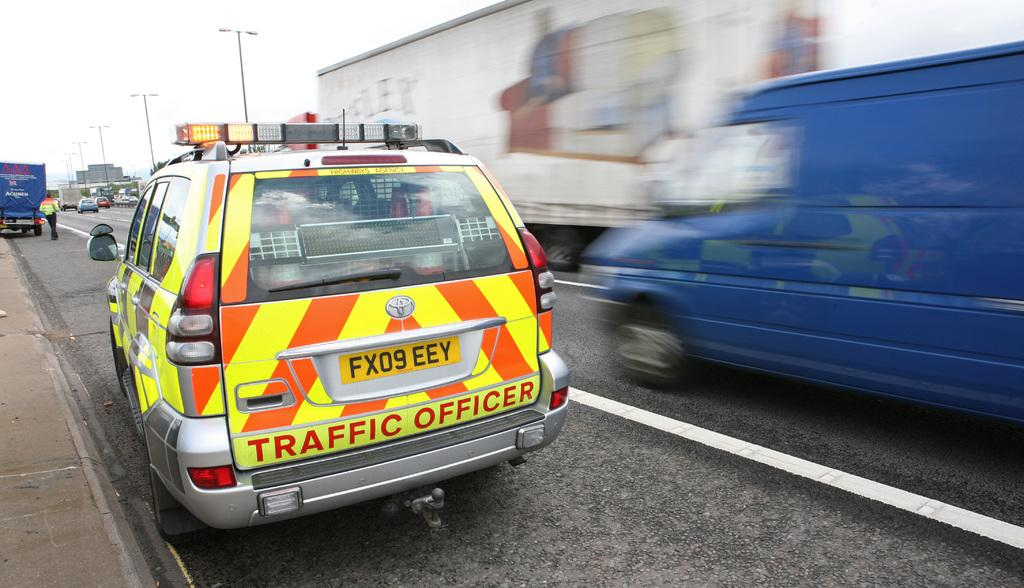<image>
Give a short and clear explanation of the subsequent image. A bright yellow and orange vehicle of a Traffic Officer. 